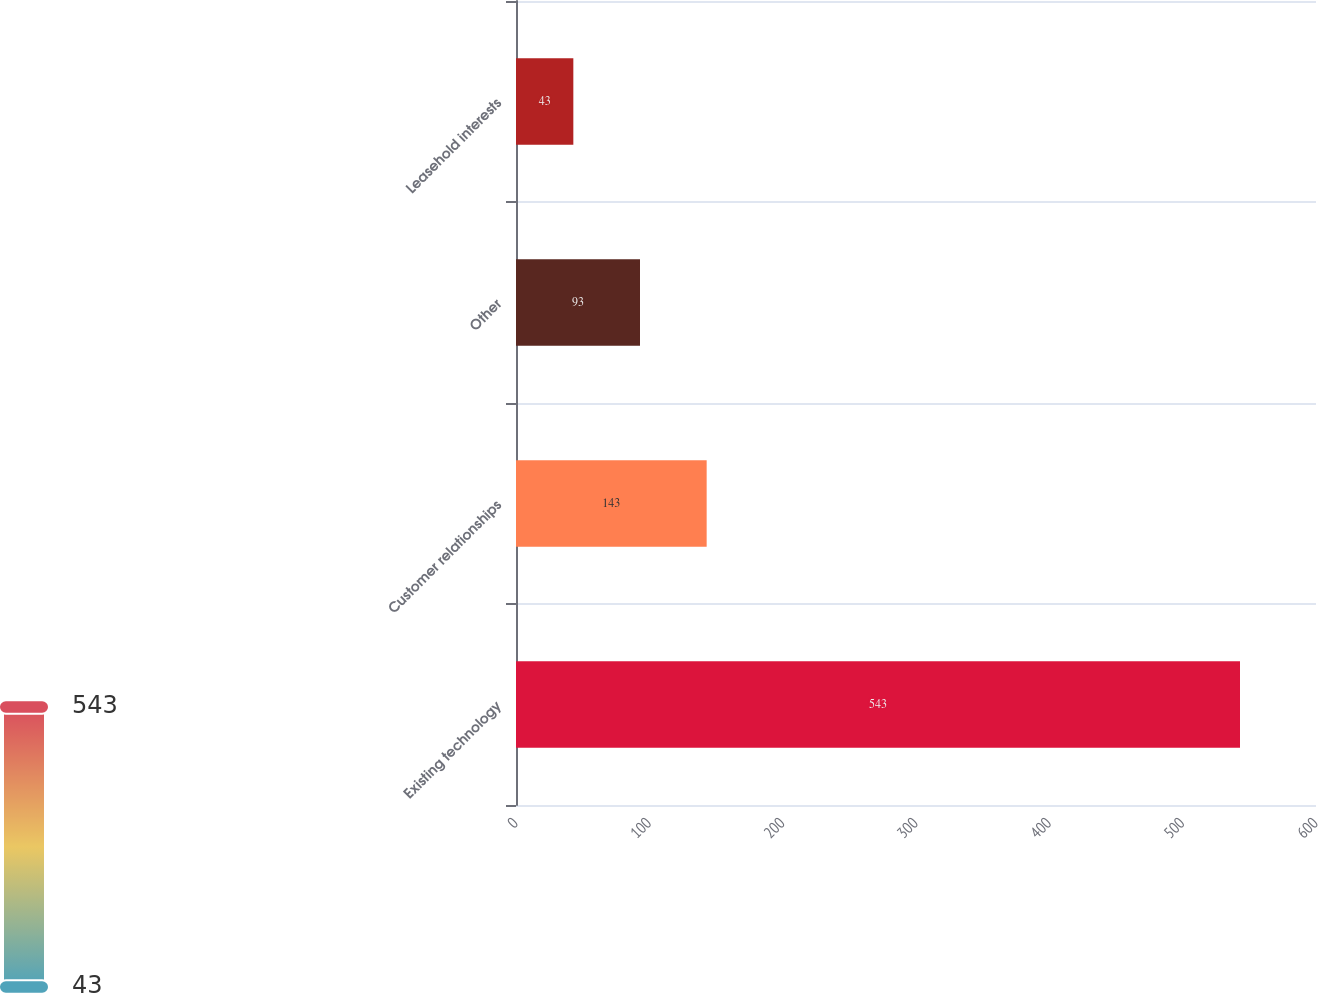<chart> <loc_0><loc_0><loc_500><loc_500><bar_chart><fcel>Existing technology<fcel>Customer relationships<fcel>Other<fcel>Leasehold interests<nl><fcel>543<fcel>143<fcel>93<fcel>43<nl></chart> 